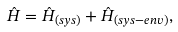<formula> <loc_0><loc_0><loc_500><loc_500>\hat { H } = \hat { H } _ { ( s y s ) } + \hat { H } _ { ( s y s - e n v ) } ,</formula> 